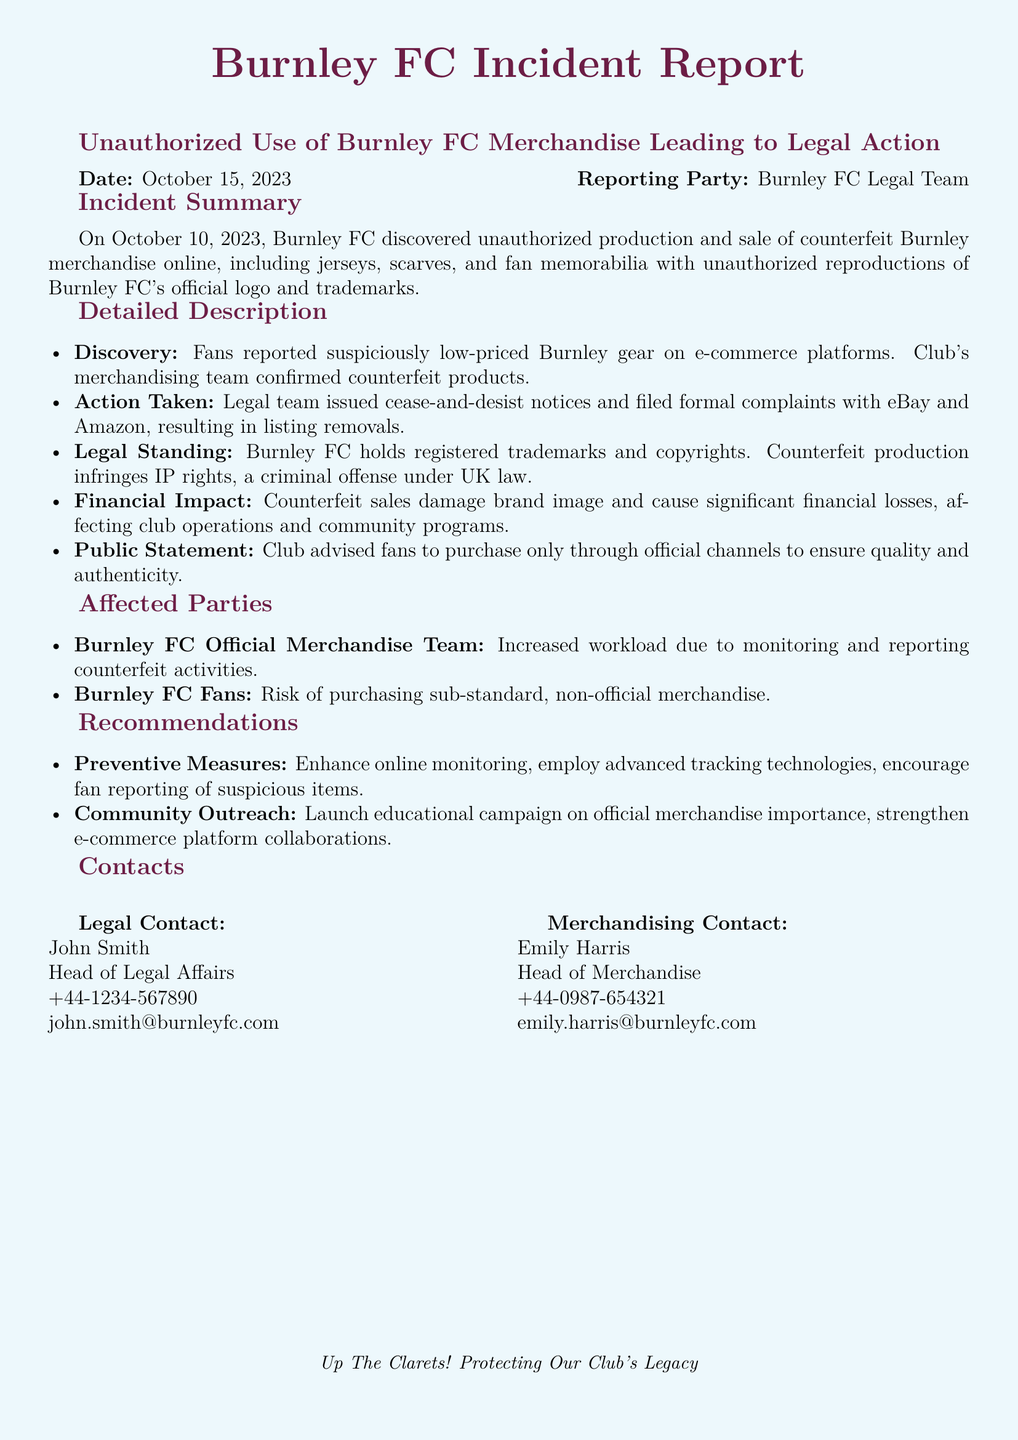What date was the incident reported? The date of the incident is clearly stated at the top of the document.
Answer: October 15, 2023 Who reported the incident? The reporting party is identified in the header of the incident report.
Answer: Burnley FC Legal Team What was discovered on October 10, 2023? The detailed description section explains the unauthorized activity that took place on this date.
Answer: Unauthorized production and sale of counterfeit Burnley merchandise What action did the legal team take against the counterfeit products? The detailed description lists the immediate actions taken by the legal team following the discovery.
Answer: Issued cease-and-desist notices What impact do counterfeit sales have on Burnley FC? The financial impact section discusses the consequences of counterfeit sales on the club.
Answer: Significant financial losses What is one recommendation for preventing future counterfeits? The recommendations section suggests actions to mitigate future instances of counterfeiting.
Answer: Enhance online monitoring Who heads the legal affairs at Burnley FC? The contacts section provides the names and titles of key personnel involved in the incident.
Answer: John Smith What type of products were counterfeited? The incident summary outlines the types of merchandise that were involved in the incident.
Answer: Jerseys, scarves, and fan memorabilia 